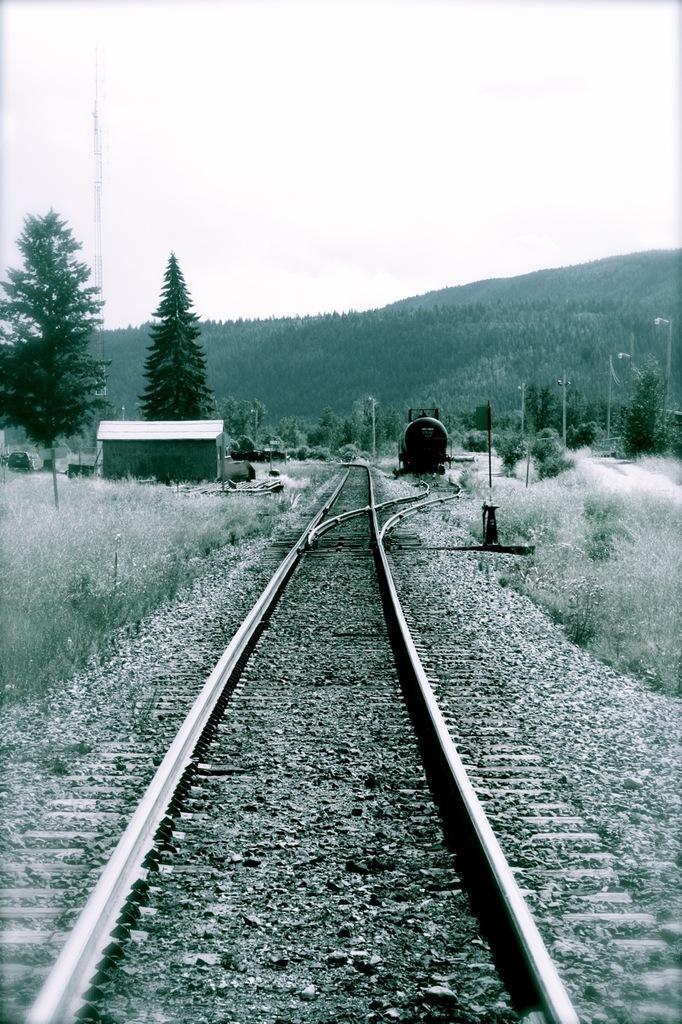Could you give a brief overview of what you see in this image? In this picture we can see a long railway track with bushes and trees on either side. Far away we can see mountains and sky. 